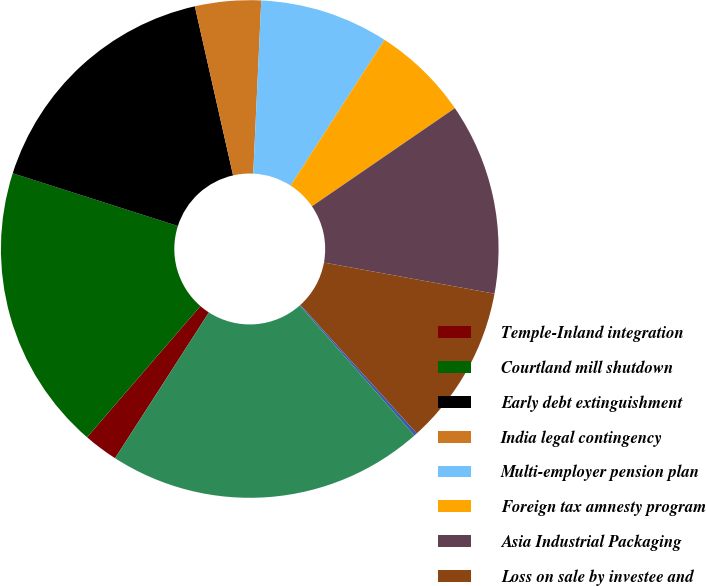Convert chart to OTSL. <chart><loc_0><loc_0><loc_500><loc_500><pie_chart><fcel>Temple-Inland integration<fcel>Courtland mill shutdown<fcel>Early debt extinguishment<fcel>India legal contingency<fcel>Multi-employer pension plan<fcel>Foreign tax amnesty program<fcel>Asia Industrial Packaging<fcel>Loss on sale by investee and<fcel>Other items<fcel>Total special items<nl><fcel>2.24%<fcel>18.58%<fcel>16.54%<fcel>4.28%<fcel>8.37%<fcel>6.32%<fcel>12.45%<fcel>10.41%<fcel>0.2%<fcel>20.62%<nl></chart> 